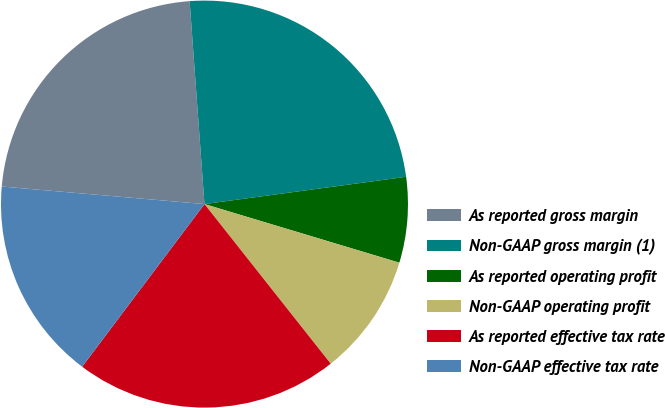Convert chart. <chart><loc_0><loc_0><loc_500><loc_500><pie_chart><fcel>As reported gross margin<fcel>Non-GAAP gross margin (1)<fcel>As reported operating profit<fcel>Non-GAAP operating profit<fcel>As reported effective tax rate<fcel>Non-GAAP effective tax rate<nl><fcel>22.46%<fcel>24.02%<fcel>6.79%<fcel>9.7%<fcel>20.91%<fcel>16.11%<nl></chart> 